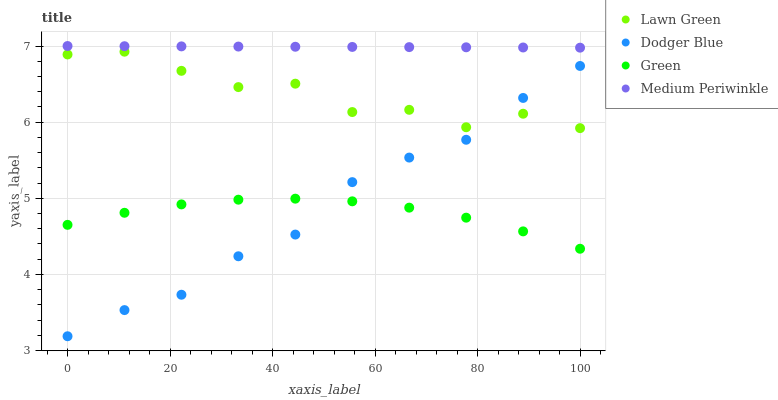Does Green have the minimum area under the curve?
Answer yes or no. Yes. Does Medium Periwinkle have the maximum area under the curve?
Answer yes or no. Yes. Does Dodger Blue have the minimum area under the curve?
Answer yes or no. No. Does Dodger Blue have the maximum area under the curve?
Answer yes or no. No. Is Medium Periwinkle the smoothest?
Answer yes or no. Yes. Is Lawn Green the roughest?
Answer yes or no. Yes. Is Green the smoothest?
Answer yes or no. No. Is Green the roughest?
Answer yes or no. No. Does Dodger Blue have the lowest value?
Answer yes or no. Yes. Does Green have the lowest value?
Answer yes or no. No. Does Medium Periwinkle have the highest value?
Answer yes or no. Yes. Does Dodger Blue have the highest value?
Answer yes or no. No. Is Dodger Blue less than Medium Periwinkle?
Answer yes or no. Yes. Is Medium Periwinkle greater than Lawn Green?
Answer yes or no. Yes. Does Dodger Blue intersect Green?
Answer yes or no. Yes. Is Dodger Blue less than Green?
Answer yes or no. No. Is Dodger Blue greater than Green?
Answer yes or no. No. Does Dodger Blue intersect Medium Periwinkle?
Answer yes or no. No. 